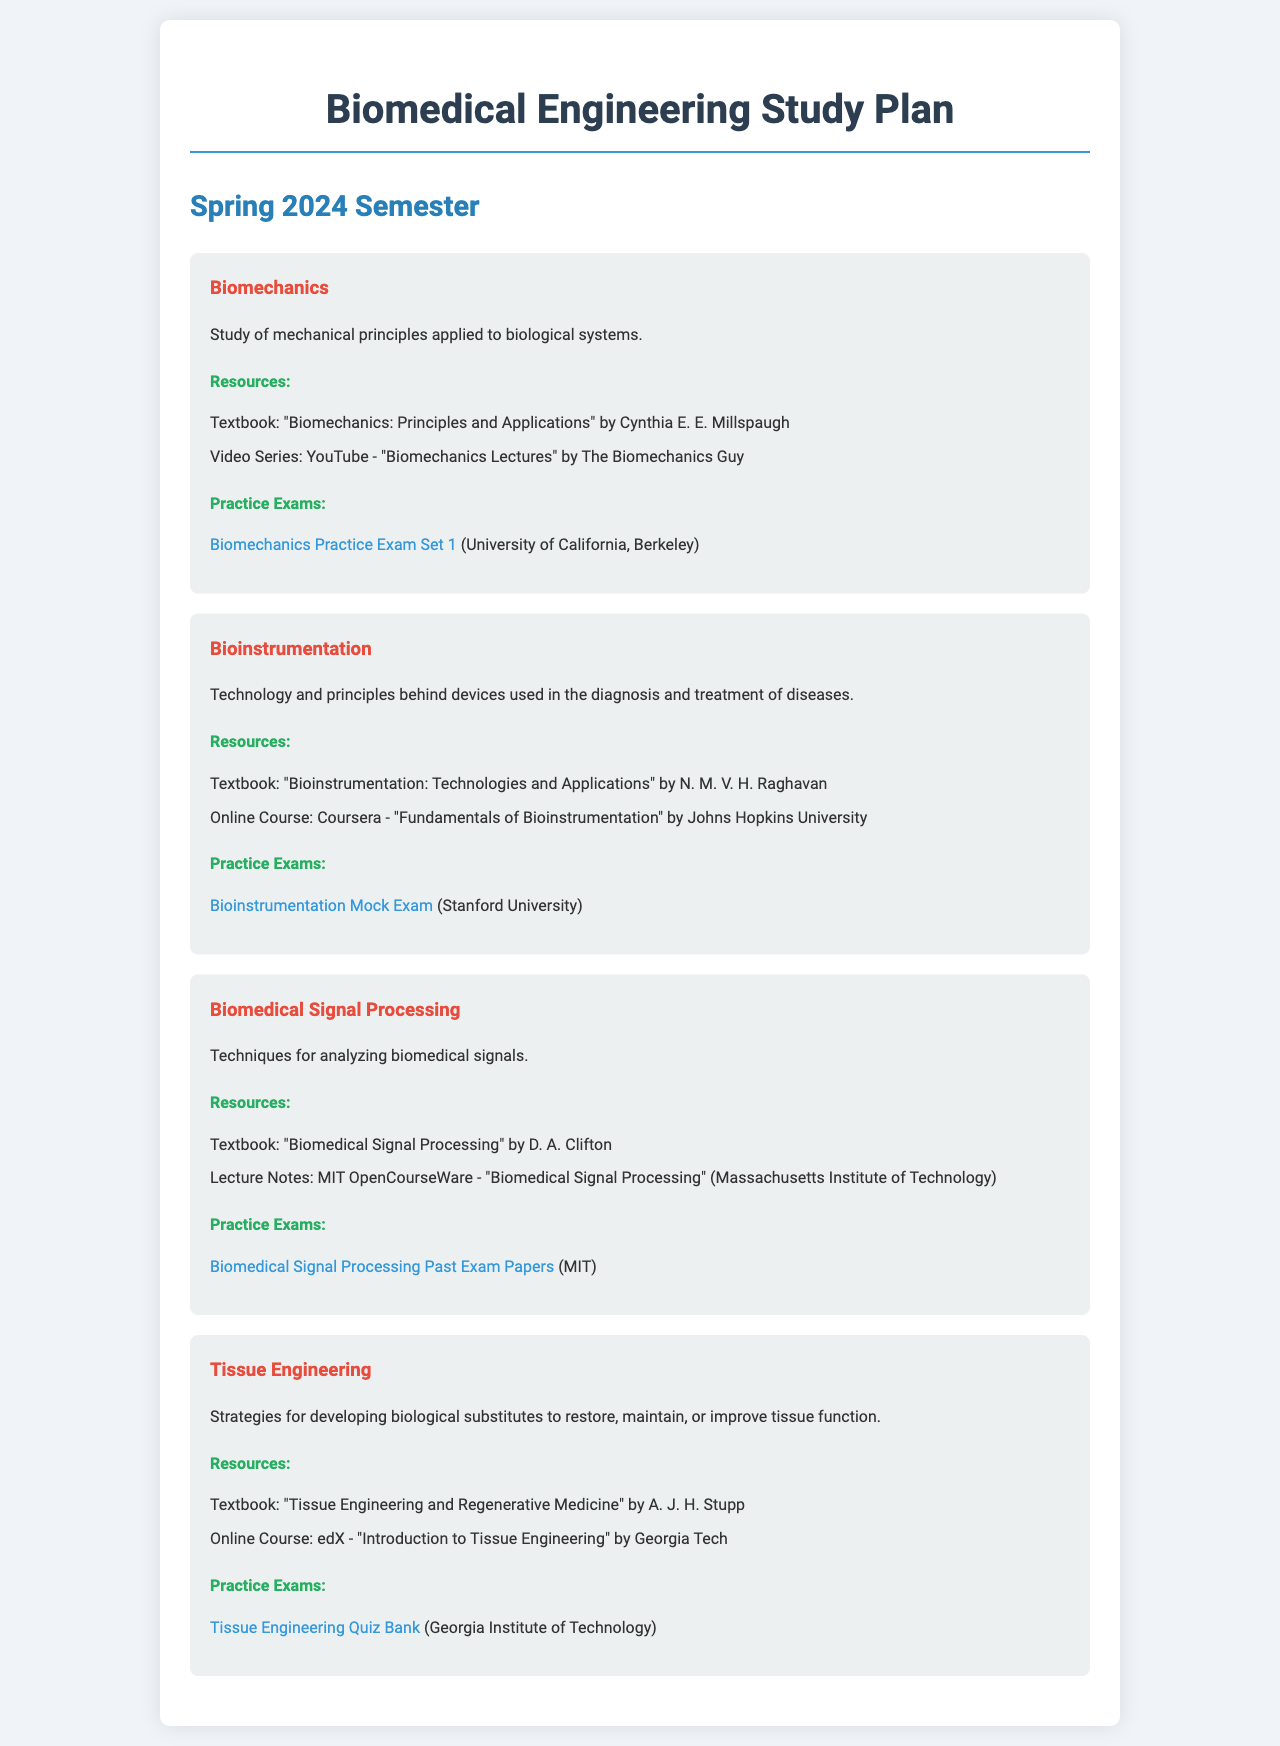What is the title of the study plan? The title clearly stated at the top of the document is for the study plan.
Answer: Biomedical Engineering Study Plan How many subjects are outlined in the document? The document lists four different subjects in the outline.
Answer: 4 What is the textbook for Biomechanics? The document specifies the recommended textbook for Biomechanics under the resources section.
Answer: "Biomechanics: Principles and Applications" by Cynthia E. E. Millspaugh What online course is suggested for Bioinstrumentation? The document mentions an online course related to Bioinstrumentation provided by a specific university.
Answer: "Fundamentals of Bioinstrumentation" by Johns Hopkins University What is the focus of Biomedical Signal Processing? The document includes a brief description of what Biomedical Signal Processing entails.
Answer: Techniques for analyzing biomedical signals Which university provides a mock exam for Bioinstrumentation? The document states where the mock exam for Bioinstrumentation is available.
Answer: Stanford University What online platform offers the course on Tissue Engineering? The document mentions a specific online learning platform associated with the Tissue Engineering course.
Answer: edX What is the link to the practice exam for Biomechanics? The document provides a specific link for the Biomechanics practice exam titled.
Answer: https://example.com/ucb_biomechanics_exam1 